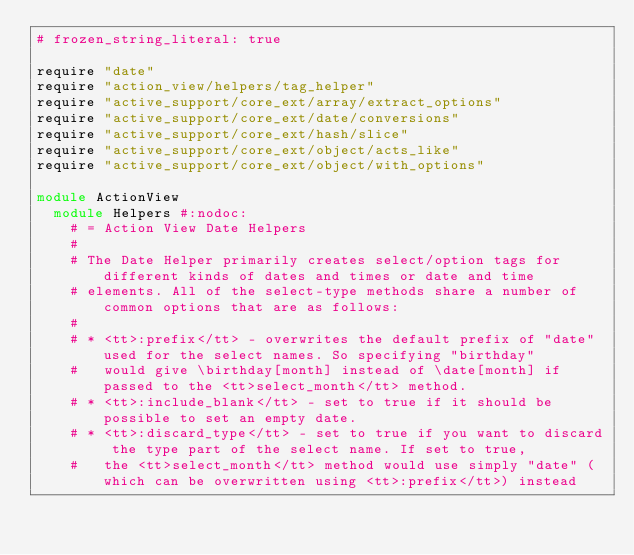Convert code to text. <code><loc_0><loc_0><loc_500><loc_500><_Ruby_># frozen_string_literal: true

require "date"
require "action_view/helpers/tag_helper"
require "active_support/core_ext/array/extract_options"
require "active_support/core_ext/date/conversions"
require "active_support/core_ext/hash/slice"
require "active_support/core_ext/object/acts_like"
require "active_support/core_ext/object/with_options"

module ActionView
  module Helpers #:nodoc:
    # = Action View Date Helpers
    #
    # The Date Helper primarily creates select/option tags for different kinds of dates and times or date and time
    # elements. All of the select-type methods share a number of common options that are as follows:
    #
    # * <tt>:prefix</tt> - overwrites the default prefix of "date" used for the select names. So specifying "birthday"
    #   would give \birthday[month] instead of \date[month] if passed to the <tt>select_month</tt> method.
    # * <tt>:include_blank</tt> - set to true if it should be possible to set an empty date.
    # * <tt>:discard_type</tt> - set to true if you want to discard the type part of the select name. If set to true,
    #   the <tt>select_month</tt> method would use simply "date" (which can be overwritten using <tt>:prefix</tt>) instead</code> 